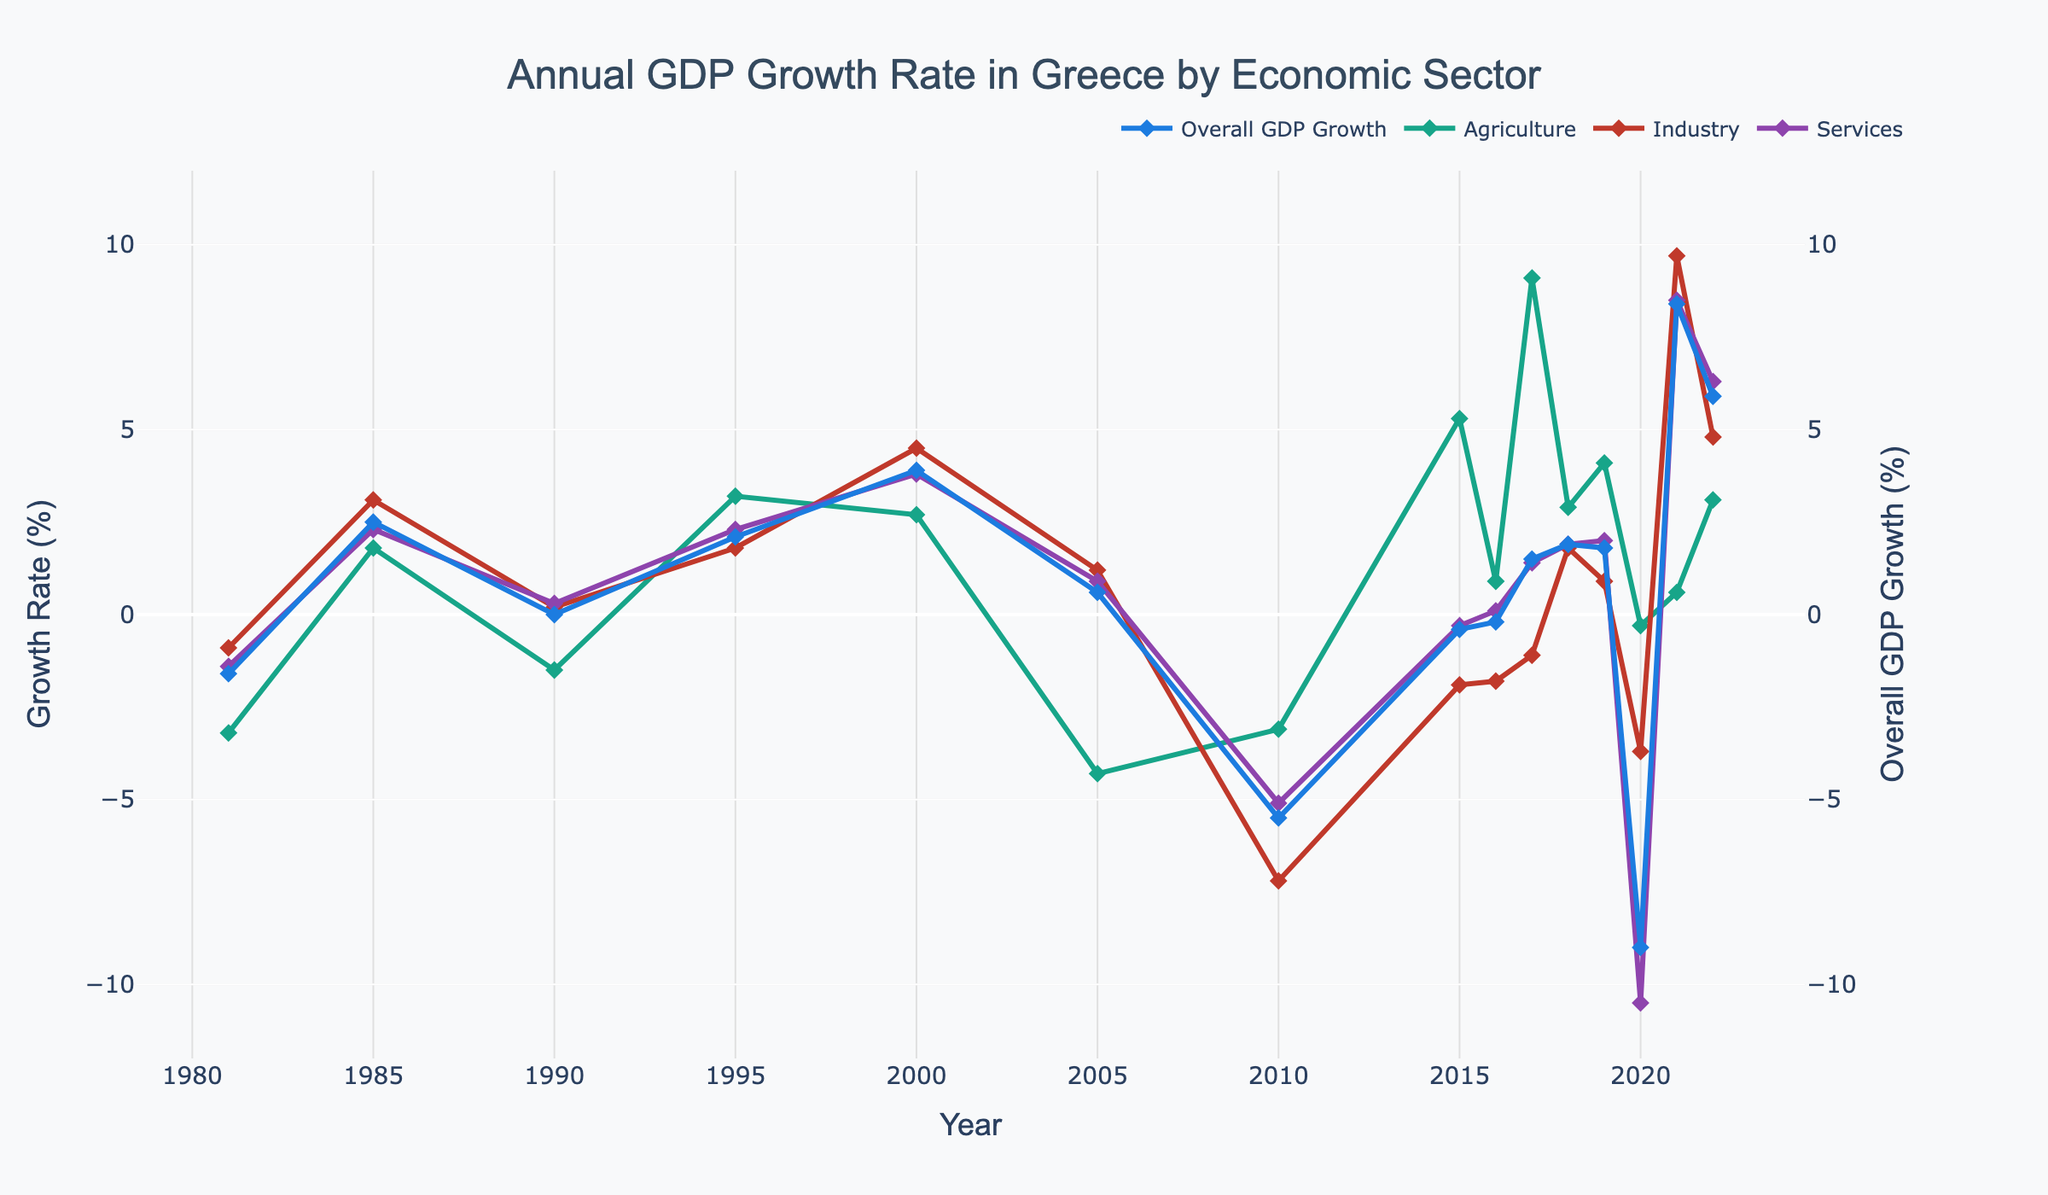which year shows the highest overall GDP growth? The highest overall GDP growth is represented by the tallest marker on the dark blue line. From the chart, the tallest marker appears in 2021.
Answer: 2021 how does the agriculture sector growth in 2010 compare to that in 2020? The growth rate for the agriculture sector in 2010 and 2020 can be compared by looking at the corresponding markers on the green line. In 2010, the growth rate for agriculture is around -3.1%, and in 2020, it is around -0.3%. The growth rate of agriculture in 2020 is higher than in 2010.
Answer: Agriculture sector growth in 2020 (-0.3%) is higher than in 2010 (-3.1%) what is the average GDP growth for the years 2018 and 2019? To find the average GDP growth for 2018 and 2019, sum the GDP growth rates for these years and divide by 2. In 2018, it is 1.9%, and in 2019, it is 1.8%. So, the average is (1.9 + 1.8) / 2 = 1.85%
Answer: 1.85% which sector shows the most significant decline in growth in 2020? The sector with the most significant decline is represented by the lowest point on its respective line in 2020. The red line representing the services sector shows the lowest point in 2020 at around -10.5%
Answer: Services sector how does the growth of the industry sector in 2000 compare to its growth in 2005? Compare the markers on the purple line for the years 2000 and 2005. In 2000, the industry growth rate is approximately 4.5%, while in 2005, it is around 1.2%. The industry growth in 2000 is higher than in 2005.
Answer: Industry sector growth in 2000 (4.5%) is higher than in 2005 (1.2%) which sector experienced the highest growth rate in 2021? The highest growth rate can be identified by looking for the tallest marker in any sector line for the year 2021. The industry sector, represented by the purple line, shows the highest growth rate at around 9.7%.
Answer: Industry sector what is the difference in overall GDP growth between 1981 and 1990? The difference can be calculated by subtracting the growth rate in 1981 from that in 1990. In 1981, the growth rate is -1.6%, and in 1990, it is 0.0%. The difference is 0.0% - (-1.6%) = 1.6%.
Answer: 1.6% was there any year when all three sectors had negative growth while the overall GDP growth was positive? To find such a year, look for a year where the overall GDP growth (dark blue line) is above 0%, while the markers for agriculture (green line), industry (red line), and services (purple line) are all below 0%. There is no such year in the chart.
Answer: No compare the services sector growth in 2015 and 2016. Compare the markers on the red line for the years 2015 and 2016. In 2015, the services sector growth rate is around -0.3%, and in 2016, it is around 0.1%. The services sector growth is higher in 2016 than in 2015.
Answer: Services sector growth is higher in 2016 (0.1%) than in 2015 (-0.3%) 